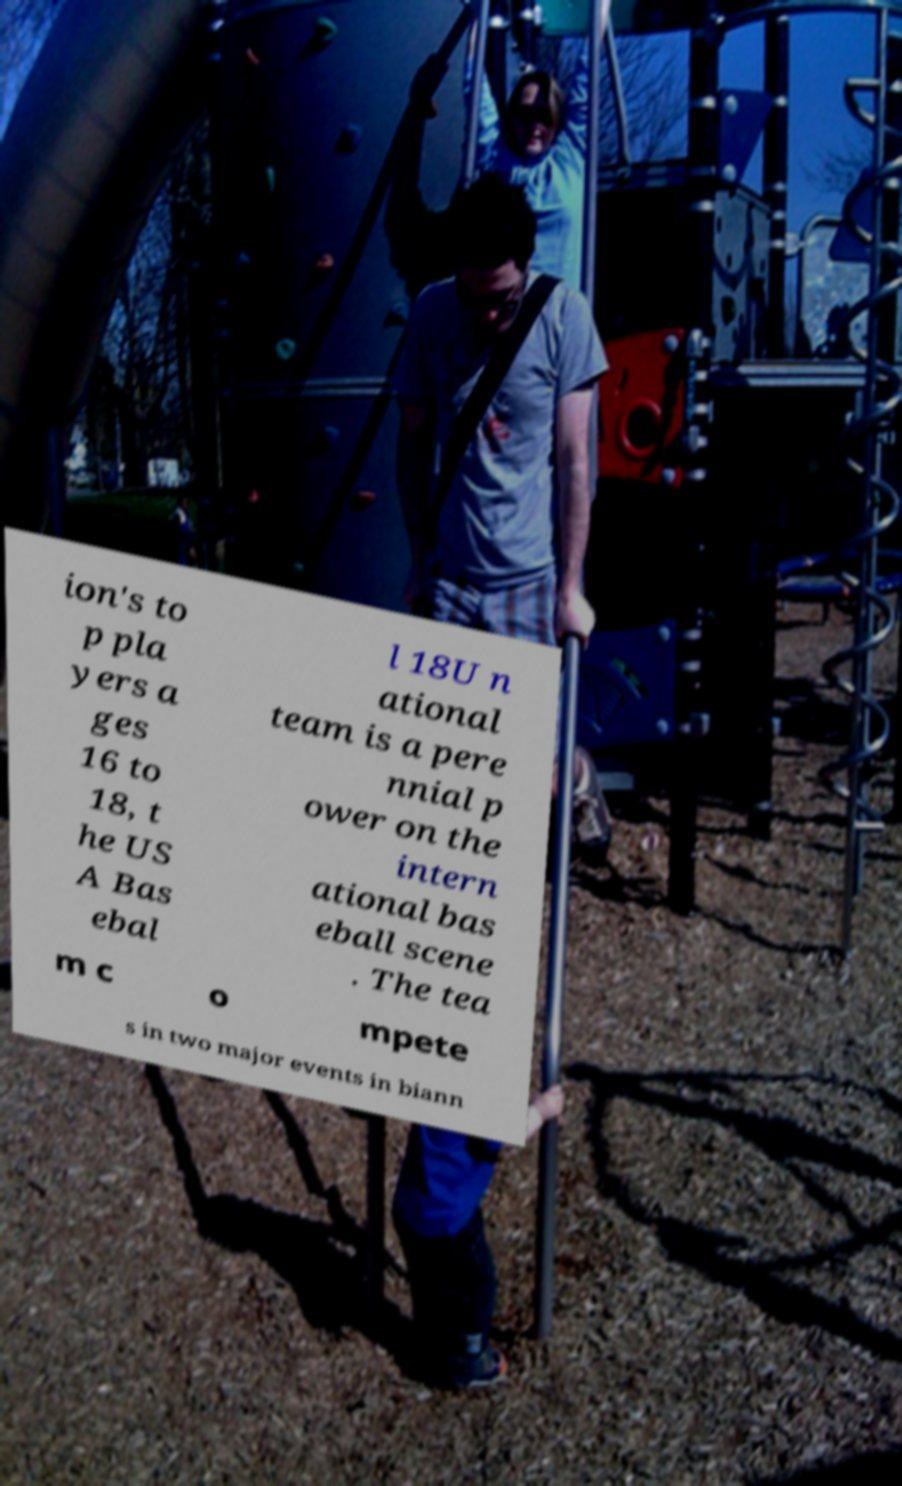What messages or text are displayed in this image? I need them in a readable, typed format. ion's to p pla yers a ges 16 to 18, t he US A Bas ebal l 18U n ational team is a pere nnial p ower on the intern ational bas eball scene . The tea m c o mpete s in two major events in biann 